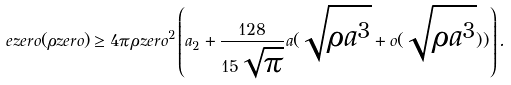Convert formula to latex. <formula><loc_0><loc_0><loc_500><loc_500>\ e z e r o ( \rho z e r o ) \geq 4 \pi \rho z e r o ^ { 2 } \left ( a _ { 2 } + \frac { 1 2 8 } { 1 5 \sqrt { \pi } } a ( \sqrt { \rho a ^ { 3 } } + o ( \sqrt { \rho a ^ { 3 } } ) ) \right ) .</formula> 